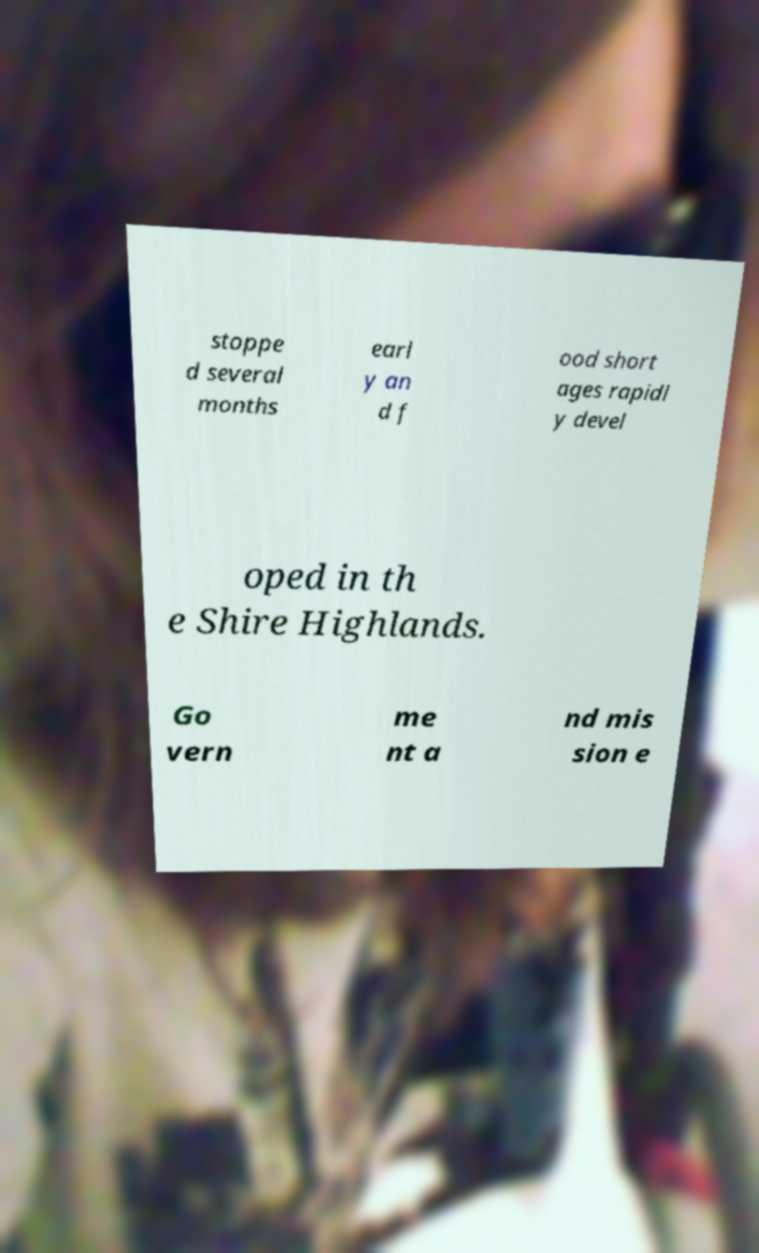Please identify and transcribe the text found in this image. stoppe d several months earl y an d f ood short ages rapidl y devel oped in th e Shire Highlands. Go vern me nt a nd mis sion e 